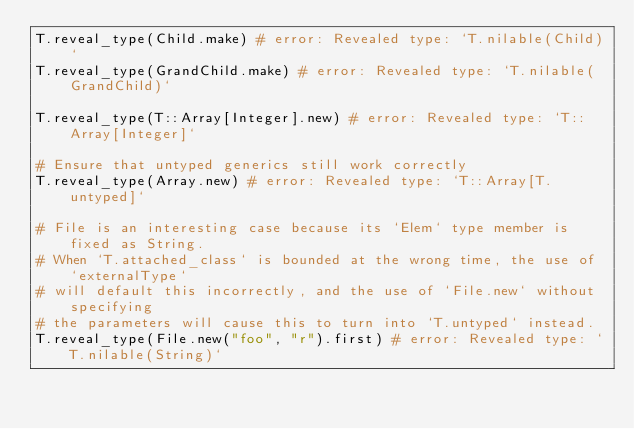Convert code to text. <code><loc_0><loc_0><loc_500><loc_500><_Ruby_>T.reveal_type(Child.make) # error: Revealed type: `T.nilable(Child)`
T.reveal_type(GrandChild.make) # error: Revealed type: `T.nilable(GrandChild)`

T.reveal_type(T::Array[Integer].new) # error: Revealed type: `T::Array[Integer]`

# Ensure that untyped generics still work correctly
T.reveal_type(Array.new) # error: Revealed type: `T::Array[T.untyped]`

# File is an interesting case because its `Elem` type member is fixed as String.
# When `T.attached_class` is bounded at the wrong time, the use of `externalType`
# will default this incorrectly, and the use of `File.new` without specifying
# the parameters will cause this to turn into `T.untyped` instead.
T.reveal_type(File.new("foo", "r").first) # error: Revealed type: `T.nilable(String)`
</code> 